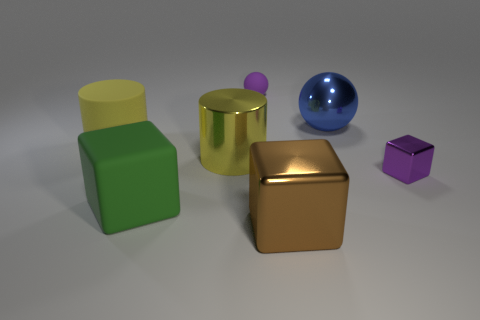Add 2 big yellow matte cylinders. How many objects exist? 9 Subtract all balls. How many objects are left? 5 Add 1 large metallic cylinders. How many large metallic cylinders are left? 2 Add 6 yellow cylinders. How many yellow cylinders exist? 8 Subtract 1 purple balls. How many objects are left? 6 Subtract all yellow metal cylinders. Subtract all large blue shiny things. How many objects are left? 5 